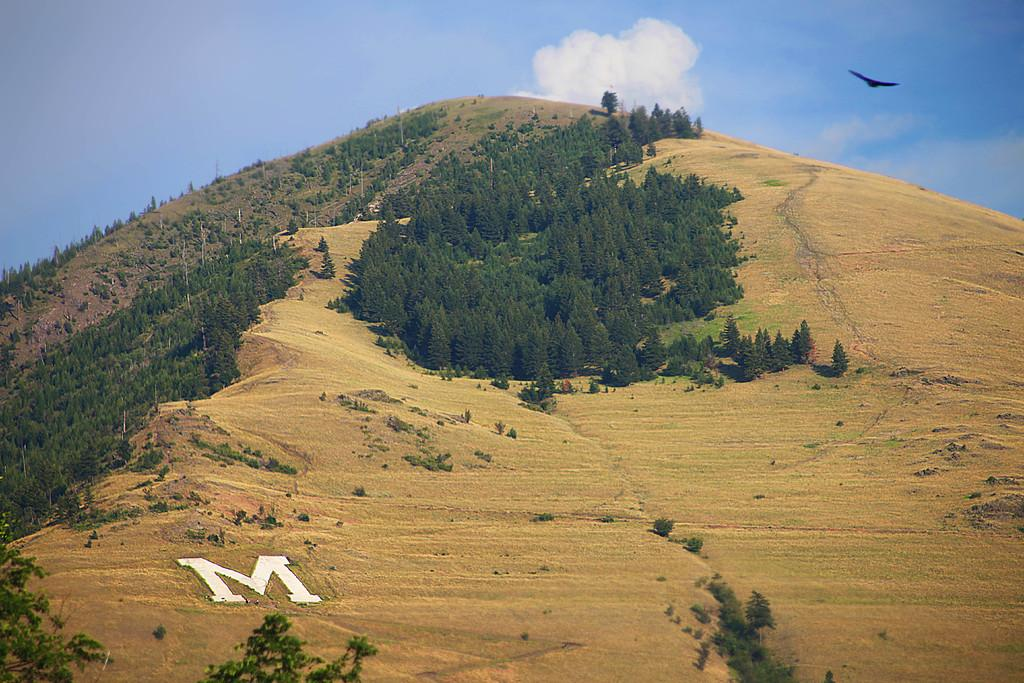What can be seen on the surface in the image? There are alphabets on the surface in the image. What type of natural environment is depicted in the image? The image features trees, a hill, grass, and a bird in the air. What is visible in the background of the image? The sky is visible in the background of the image, with clouds present. How does the heart change its color in the image? There is no heart present in the image, so its color cannot be observed or changed. 